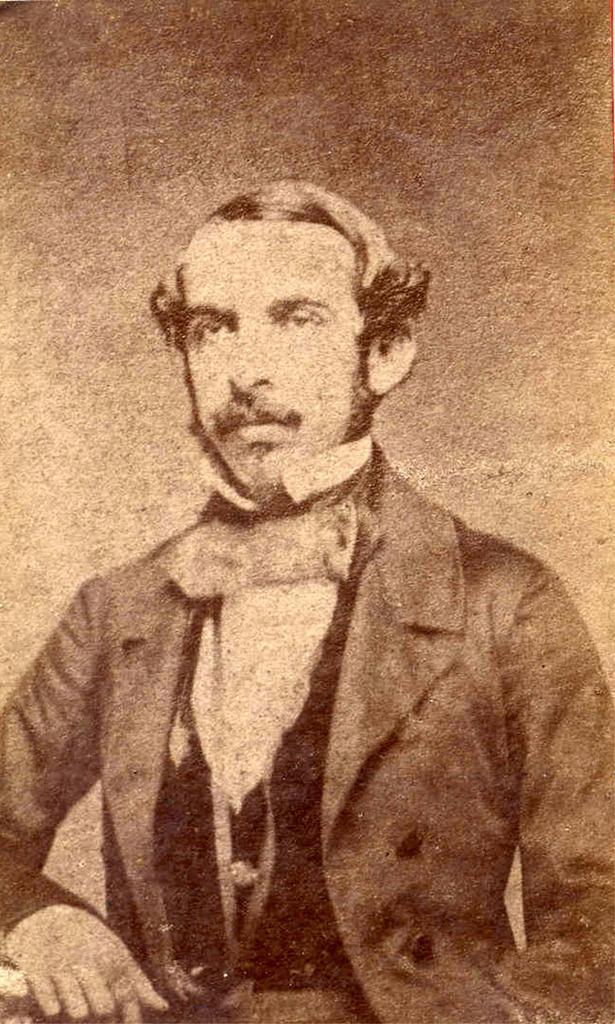Please provide a concise description of this image. It is a black and white picture, in this a man is there. He wore a coat. 